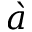Convert formula to latex. <formula><loc_0><loc_0><loc_500><loc_500>\grave { a }</formula> 